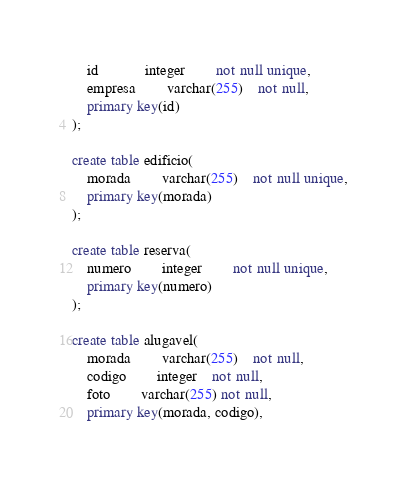<code> <loc_0><loc_0><loc_500><loc_500><_SQL_>	id		 	integer		not null unique,
	empresa	 	varchar(255)	not null,
	primary key(id)
);

create table edificio(
	morada 		varchar(255)	not null unique,
	primary key(morada)
);

create table reserva(
	numero	 	integer		not null unique,
	primary key(numero)
);

create table alugavel(
	morada	 	varchar(255)	not null,
	codigo	 	integer  	not null,
	foto		varchar(255) not null,
	primary key(morada, codigo),</code> 